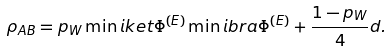<formula> <loc_0><loc_0><loc_500><loc_500>\rho _ { A B } = p _ { W } \min i k e t { \Phi ^ { ( E ) } } \min i b r a { \Phi ^ { ( E ) } } + \frac { 1 - p _ { W } } { 4 } \i d .</formula> 